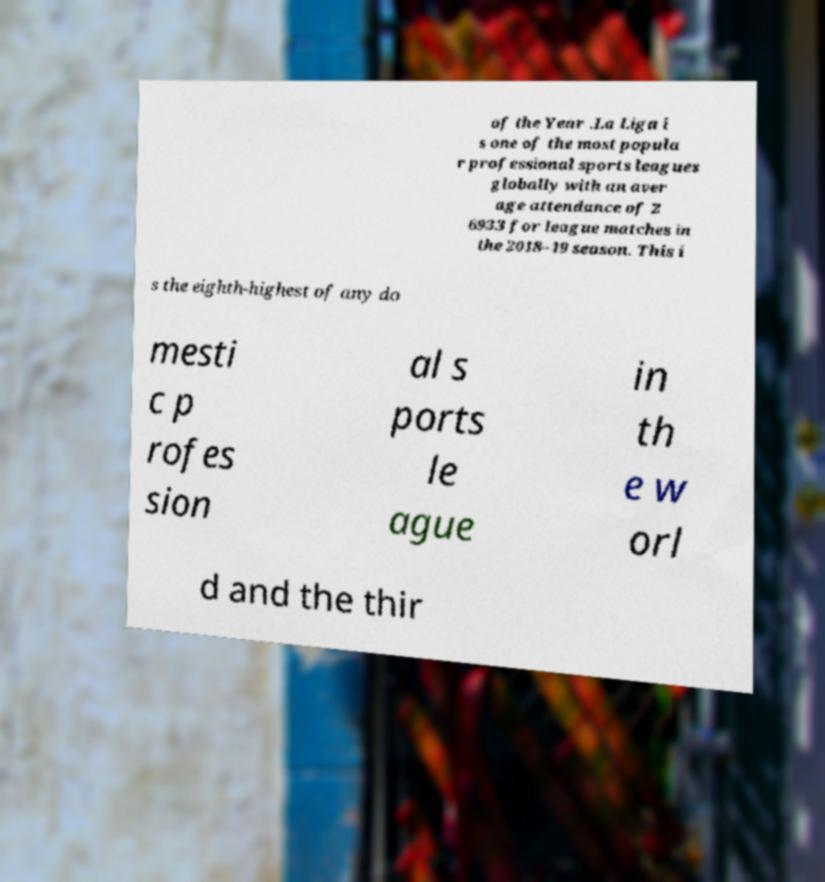Could you assist in decoding the text presented in this image and type it out clearly? of the Year .La Liga i s one of the most popula r professional sports leagues globally with an aver age attendance of 2 6933 for league matches in the 2018–19 season. This i s the eighth-highest of any do mesti c p rofes sion al s ports le ague in th e w orl d and the thir 